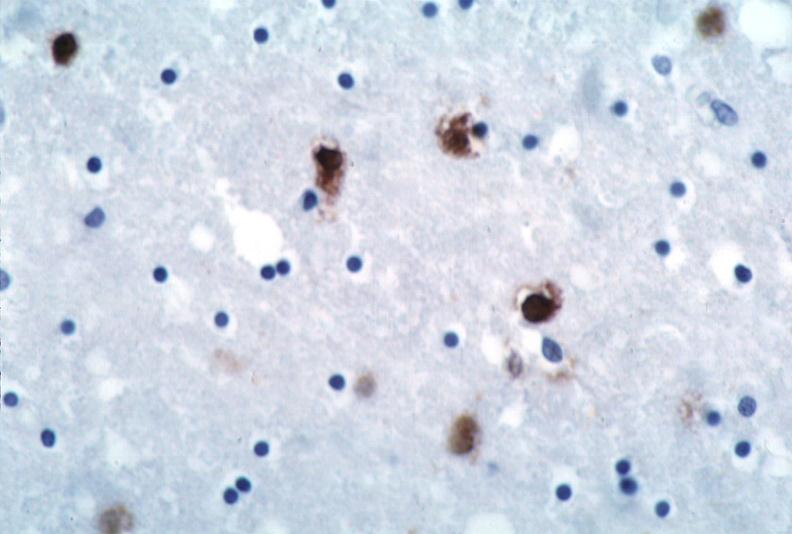does excellent close-up view show brain, herpes encephalitis?
Answer the question using a single word or phrase. No 